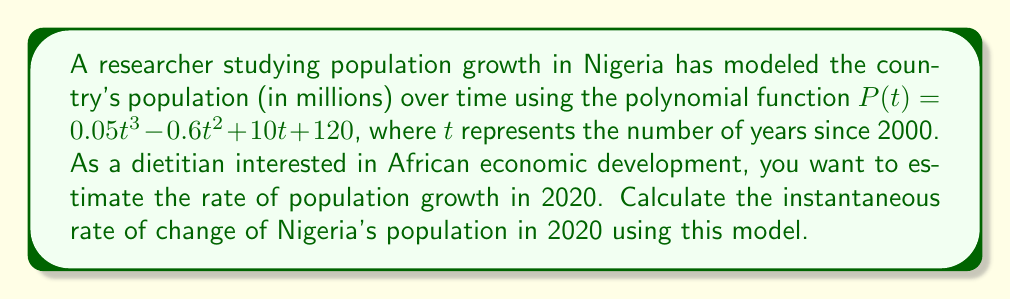Can you solve this math problem? To solve this problem, we need to follow these steps:

1) First, we need to find the derivative of the population function $P(t)$. This will give us the rate of change function.

   $P(t) = 0.05t^3 - 0.6t^2 + 10t + 120$
   $P'(t) = 0.15t^2 - 1.2t + 10$

2) The year 2020 is 20 years after 2000, so we need to evaluate $P'(20)$.

3) Let's substitute $t = 20$ into the derivative function:

   $P'(20) = 0.15(20)^2 - 1.2(20) + 10$
           $= 0.15(400) - 24 + 10$
           $= 60 - 24 + 10$
           $= 46$

4) The units of this rate are millions of people per year, as the original function was in millions and $t$ was in years.

Therefore, according to this model, the instantaneous rate of population growth in Nigeria in 2020 was 46 million people per year.
Answer: 46 million people per year 